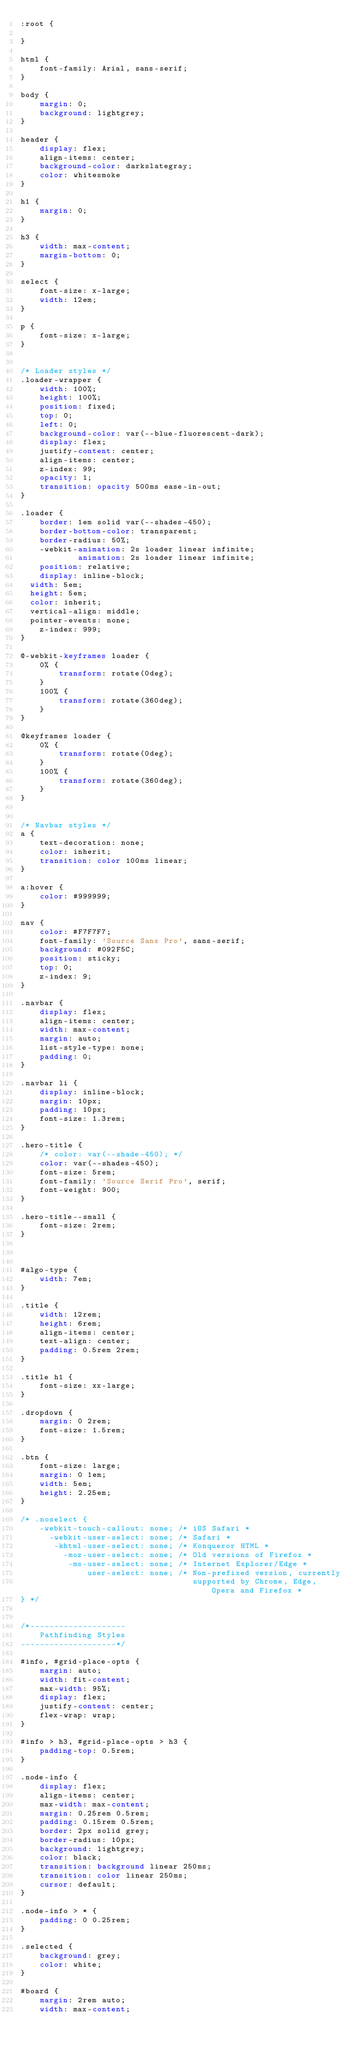<code> <loc_0><loc_0><loc_500><loc_500><_CSS_>:root {
    
}

html {
    font-family: Arial, sans-serif;
}

body {
    margin: 0;
    background: lightgrey;
}

header {
    display: flex;
    align-items: center;
    background-color: darkslategray;
    color: whitesmoke
}

h1 {
    margin: 0;
}

h3 {
    width: max-content;
    margin-bottom: 0;
}

select {
    font-size: x-large;
    width: 12em;
}

p {
    font-size: x-large;
}


/* Loader styles */
.loader-wrapper {
    width: 100%;
    height: 100%;
    position: fixed;
    top: 0;
    left: 0;
    background-color: var(--blue-fluorescent-dark);
    display: flex;
    justify-content: center;
    align-items: center;
    z-index: 99;
    opacity: 1;
    transition: opacity 500ms ease-in-out;
}

.loader {
    border: 1em solid var(--shades-450);
    border-bottom-color: transparent;
    border-radius: 50%;
    -webkit-animation: 2s loader linear infinite;
            animation: 2s loader linear infinite;
    position: relative;
    display: inline-block;
	width: 5em;
	height: 5em;
	color: inherit;
	vertical-align: middle;
	pointer-events: none;
    z-index: 999;
}

@-webkit-keyframes loader {
    0% {
        transform: rotate(0deg);
    }
    100% {
        transform: rotate(360deg);
    }
}

@keyframes loader {
    0% {
        transform: rotate(0deg);
    }
    100% {
        transform: rotate(360deg);
    }
}


/* Navbar styles */
a {
    text-decoration: none;
    color: inherit;
    transition: color 100ms linear;
}

a:hover {
    color: #999999;
}

nav {
    color: #F7F7F7;
    font-family: 'Source Sans Pro', sans-serif;
    background: #092F5C;
    position: sticky;
    top: 0;
    z-index: 9;
}

.navbar {
    display: flex;
    align-items: center;
    width: max-content;
    margin: auto;
    list-style-type: none;
    padding: 0;
}

.navbar li {
    display: inline-block;
    margin: 10px;
    padding: 10px;
    font-size: 1.3rem;
}

.hero-title {
    /* color: var(--shade-450); */
    color: var(--shades-450);
    font-size: 5rem;
    font-family: 'Source Serif Pro', serif;
    font-weight: 900;
}

.hero-title--small {
    font-size: 2rem;
}



#algo-type {
    width: 7em;
}

.title {
    width: 12rem;
    height: 6rem;
    align-items: center;
    text-align: center;
    padding: 0.5rem 2rem;
}

.title h1 {
    font-size: xx-large;
}

.dropdown {
    margin: 0 2rem;
    font-size: 1.5rem;
}

.btn {
    font-size: large;
    margin: 0 1em;
    width: 5em;
    height: 2.25em;
}

/* .noselect {
    -webkit-touch-callout: none; /* iOS Safari *
      -webkit-user-select: none; /* Safari *
       -khtml-user-select: none; /* Konqueror HTML *
         -moz-user-select: none; /* Old versions of Firefox *
          -ms-user-select: none; /* Internet Explorer/Edge *
              user-select: none; /* Non-prefixed version, currently
                                    supported by Chrome, Edge, Opera and Firefox *
} */


/*--------------------
    Pathfinding Styles
--------------------*/

#info, #grid-place-opts {
    margin: auto;
    width: fit-content;
    max-width: 95%;
    display: flex;
    justify-content: center;
    flex-wrap: wrap;
}

#info > h3, #grid-place-opts > h3 {
    padding-top: 0.5rem;
}

.node-info {
    display: flex;
    align-items: center;
    max-width: max-content;
    margin: 0.25rem 0.5rem;
    padding: 0.15rem 0.5rem;
    border: 2px solid grey;
    border-radius: 10px;
    background: lightgrey;
    color: black;
    transition: background linear 250ms;
    transition: color linear 250ms;
    cursor: default;
}

.node-info > * {
    padding: 0 0.25rem;
}

.selected {
    background: grey;
    color: white;
}

#board {
    margin: 2rem auto;
    width: max-content;</code> 